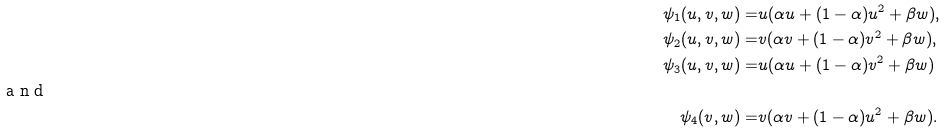<formula> <loc_0><loc_0><loc_500><loc_500>\psi _ { 1 } ( u , v , w ) = & u ( \alpha u + ( 1 - \alpha ) u ^ { 2 } + \beta w ) , \\ \psi _ { 2 } ( u , v , w ) = & v ( \alpha v + ( 1 - \alpha ) v ^ { 2 } + \beta w ) , \\ \psi _ { 3 } ( u , v , w ) = & u ( \alpha u + ( 1 - \alpha ) v ^ { 2 } + \beta w ) \shortintertext { a n d } \psi _ { 4 } ( v , w ) = & v ( \alpha v + ( 1 - \alpha ) u ^ { 2 } + \beta w ) .</formula> 